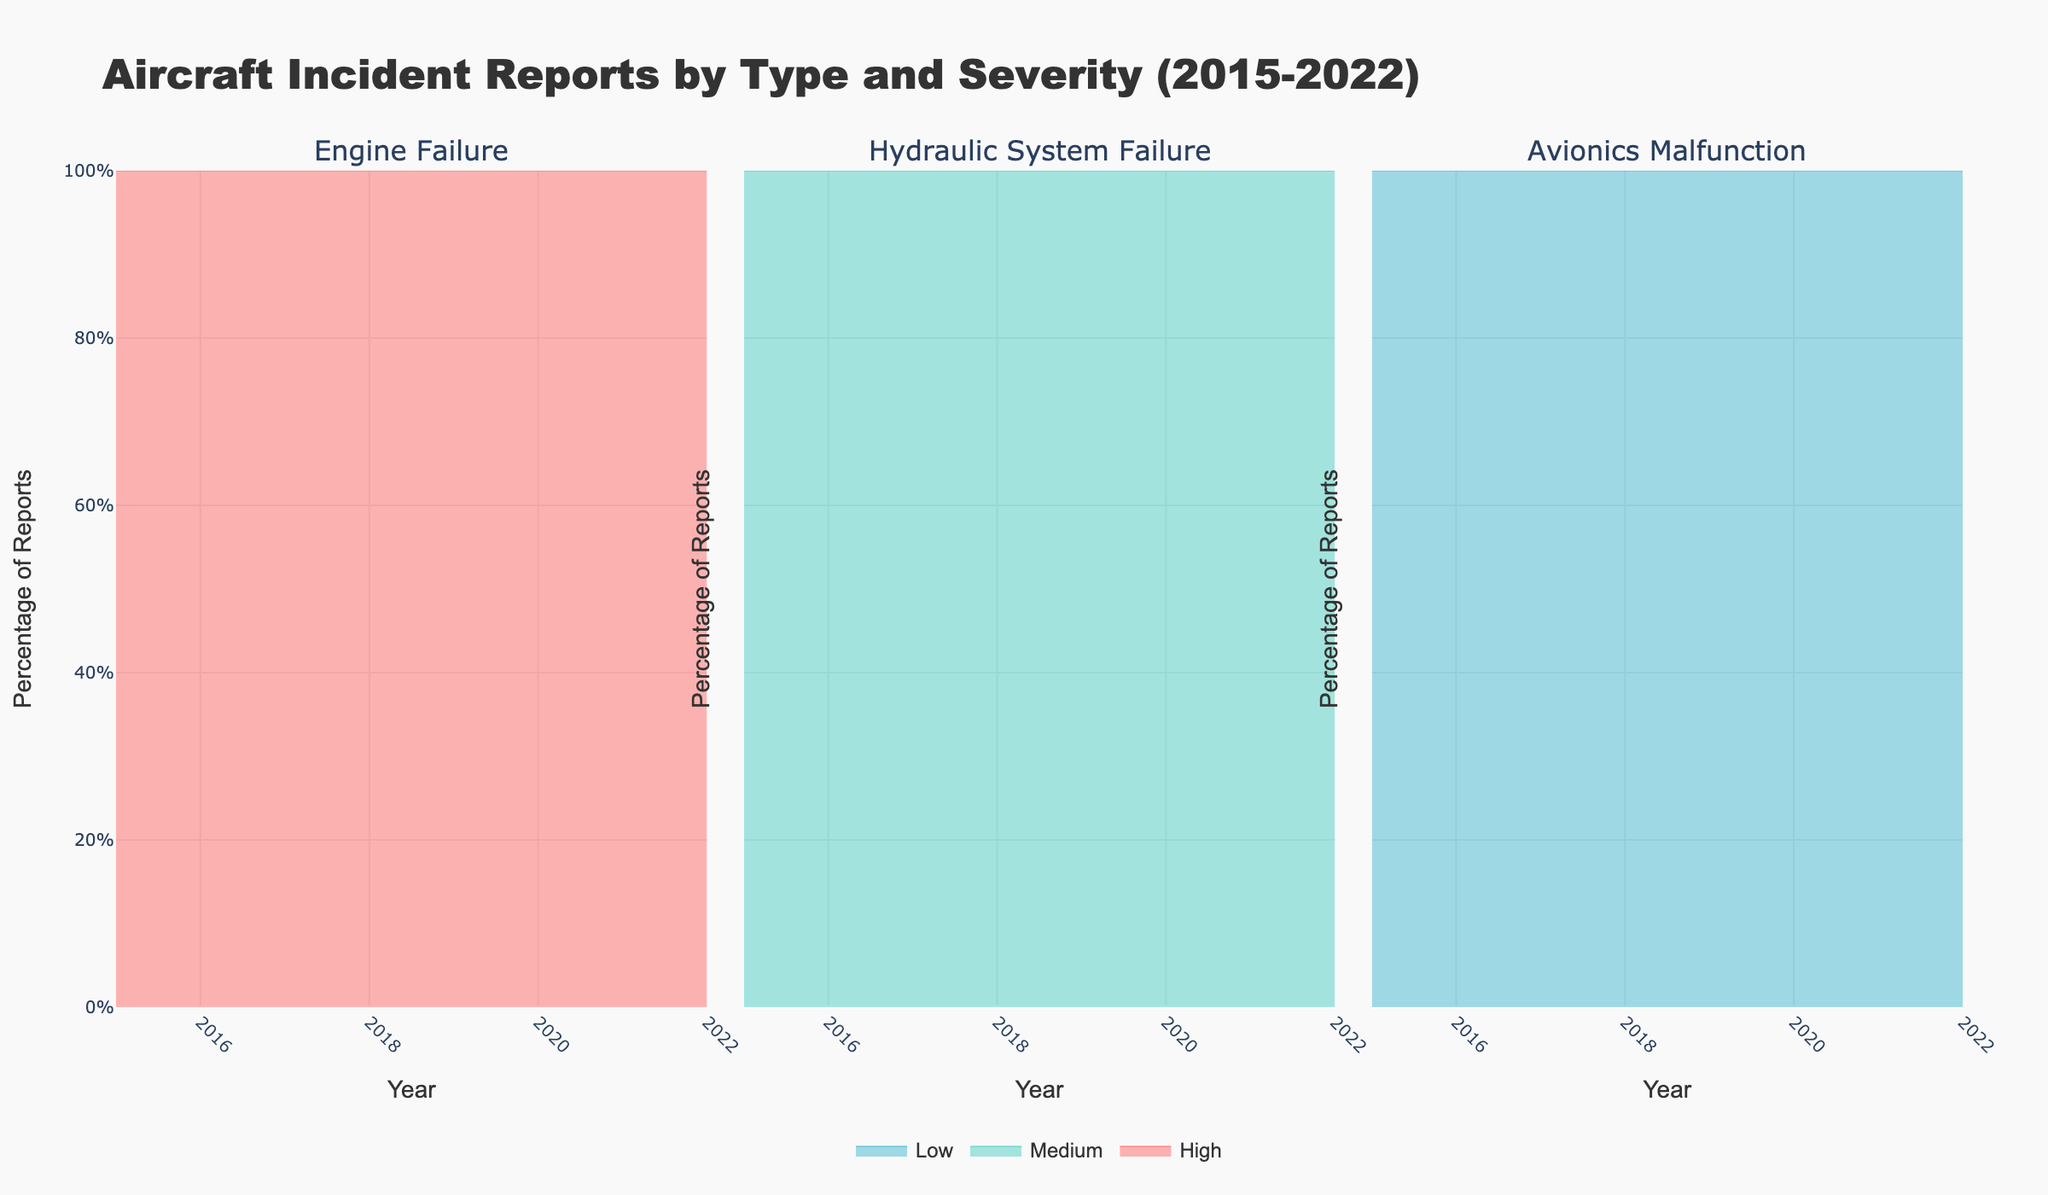What is the title of the figure? The title is usually located at the top of the figure. Referring to the top section, it reads "Aircraft Incident Reports by Type and Severity (2015-2022)"
Answer: Aircraft Incident Reports by Type and Severity (2015-2022) What are the labels on the x-axis? The labels on the x-axis typically indicate the years from the data. Observing the bottom of each subplot, the years range from 2015 to 2022.
Answer: Year (2015-2022) What does the y-axis represent? The y-axis title provides this information. Observing the left side, it indicates "Percentage of Reports", expressed in percentage.
Answer: Percentage of Reports How many subplots are there and what do they represent? The number of subplots can be visually counted, and the titles of each subplot indicate what they represent. There are three subplots, representing "Engine Failure", "Hydraulic System Failure", and "Avionics Malfunction" respectively.
Answer: 3 subplots; Engine Failure, Hydraulic System Failure, Avionics Malfunction What color represents high severity incidents? The colors corresponding to different severities are shown by the line colors in the subplots. High severity incidents are colored red.
Answer: Red Which incident type shows the highest percentage of reports in 2022 for high severity? To answer this, compare the highest points in the red areas of each subplot for the year 2022. "Engine Failure" has the highest percentage of reports for high severity in 2022.
Answer: Engine Failure Between 2017 and 2022, did the percentage of medium severity incident reports for "Hydraulic System Failure" generally increase, decrease, or stay the same? Observe the green areas in the Hydraulic System Failure subplot from 2017 to 2022. The green area generally increased, indicating an increase in the percentage of medium severity incident reports.
Answer: Increase In which year did "Engine Failure" have the lowest percentage of high severity incident reports? Look at the red area in the Engine Failure subplot and identify the year with the smallest red region. The lowest percentage of high severity incident reports for Engine Failure occurred in 2017.
Answer: 2017 How does the trend of low severity incident reports for "Avionics Malfunction" compare to high severity in the same category? Examine the blue and red areas in the Avionics Malfunction subplot. The trend shows that while the low severity (blue) reports have slight fluctuations, the high severity (red) reports have mostly remained low and stable.
Answer: Low severity fluctuated slightly; high severity remained low and stable What can be inferred about the overall trend of incident reports for medium severity over the years? Look at the green areas across all subplots from 2015 to 2022. The general trend is an increase in the percentage of reports for medium severity incidents over the years.
Answer: Increasing trend 